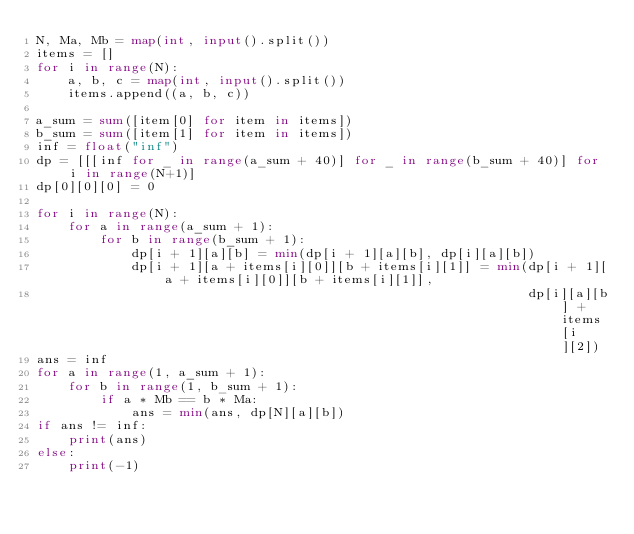Convert code to text. <code><loc_0><loc_0><loc_500><loc_500><_Python_>N, Ma, Mb = map(int, input().split())
items = []
for i in range(N):
    a, b, c = map(int, input().split())
    items.append((a, b, c))

a_sum = sum([item[0] for item in items])
b_sum = sum([item[1] for item in items])
inf = float("inf")
dp = [[[inf for _ in range(a_sum + 40)] for _ in range(b_sum + 40)] for i in range(N+1)]
dp[0][0][0] = 0

for i in range(N):
    for a in range(a_sum + 1):
        for b in range(b_sum + 1):
            dp[i + 1][a][b] = min(dp[i + 1][a][b], dp[i][a][b])
            dp[i + 1][a + items[i][0]][b + items[i][1]] = min(dp[i + 1][a + items[i][0]][b + items[i][1]],
                                                              dp[i][a][b] + items[i][2])
ans = inf
for a in range(1, a_sum + 1):
    for b in range(1, b_sum + 1):
        if a * Mb == b * Ma:
            ans = min(ans, dp[N][a][b])
if ans != inf:
    print(ans)
else:
    print(-1)</code> 